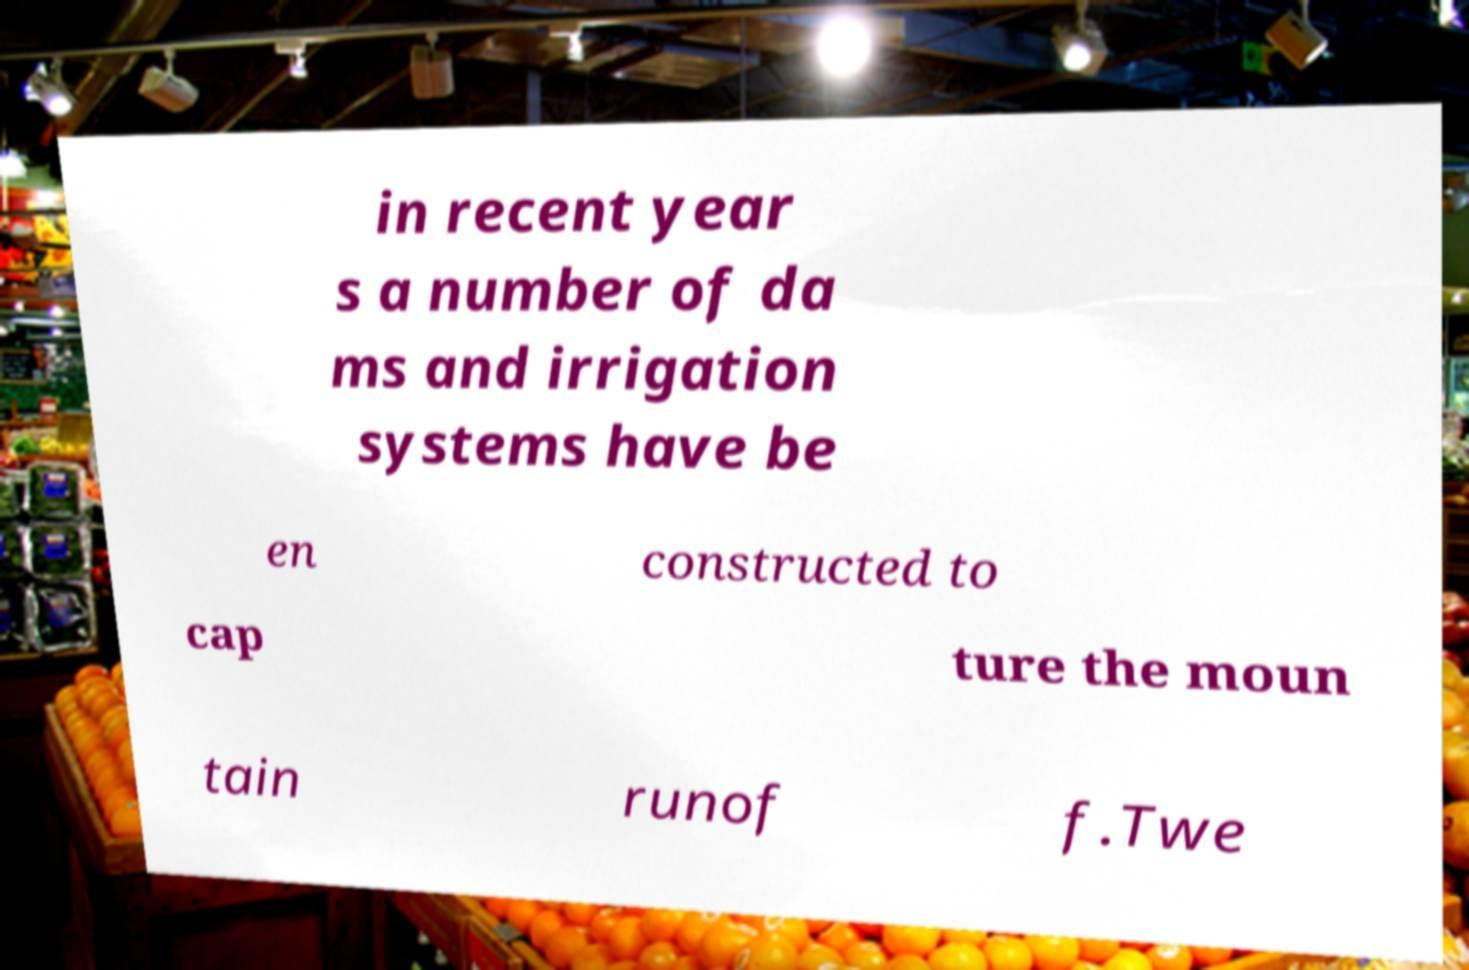Could you extract and type out the text from this image? in recent year s a number of da ms and irrigation systems have be en constructed to cap ture the moun tain runof f.Twe 